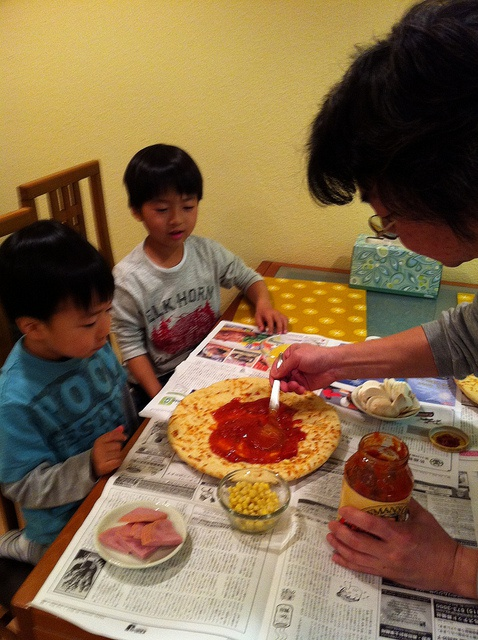Describe the objects in this image and their specific colors. I can see dining table in tan, maroon, darkgray, and gray tones, people in tan, black, maroon, brown, and gray tones, people in tan, black, blue, maroon, and darkblue tones, people in tan, black, maroon, gray, and darkgray tones, and pizza in tan, maroon, and orange tones in this image. 